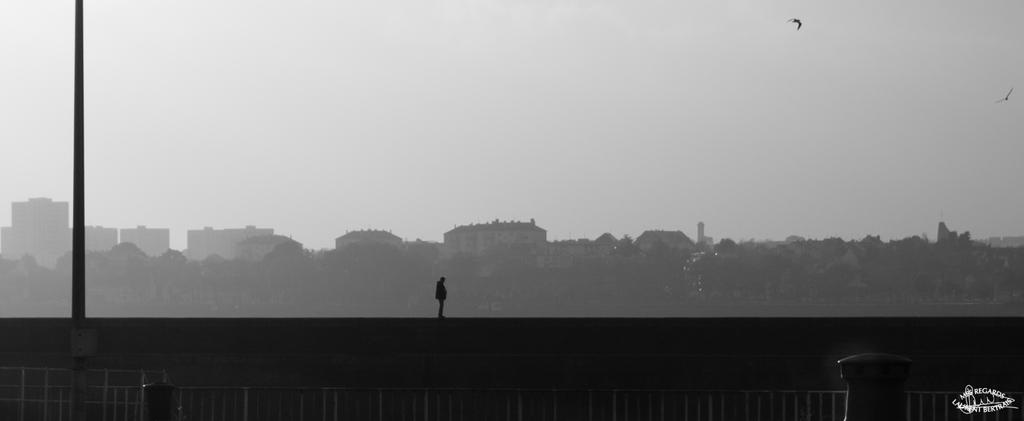Describe this image in one or two sentences. In this image there is a man standing on a wall, in the background there are trees buildings and the sky, in foreground there is a railing, pole, on the bottom right there is a logo. 